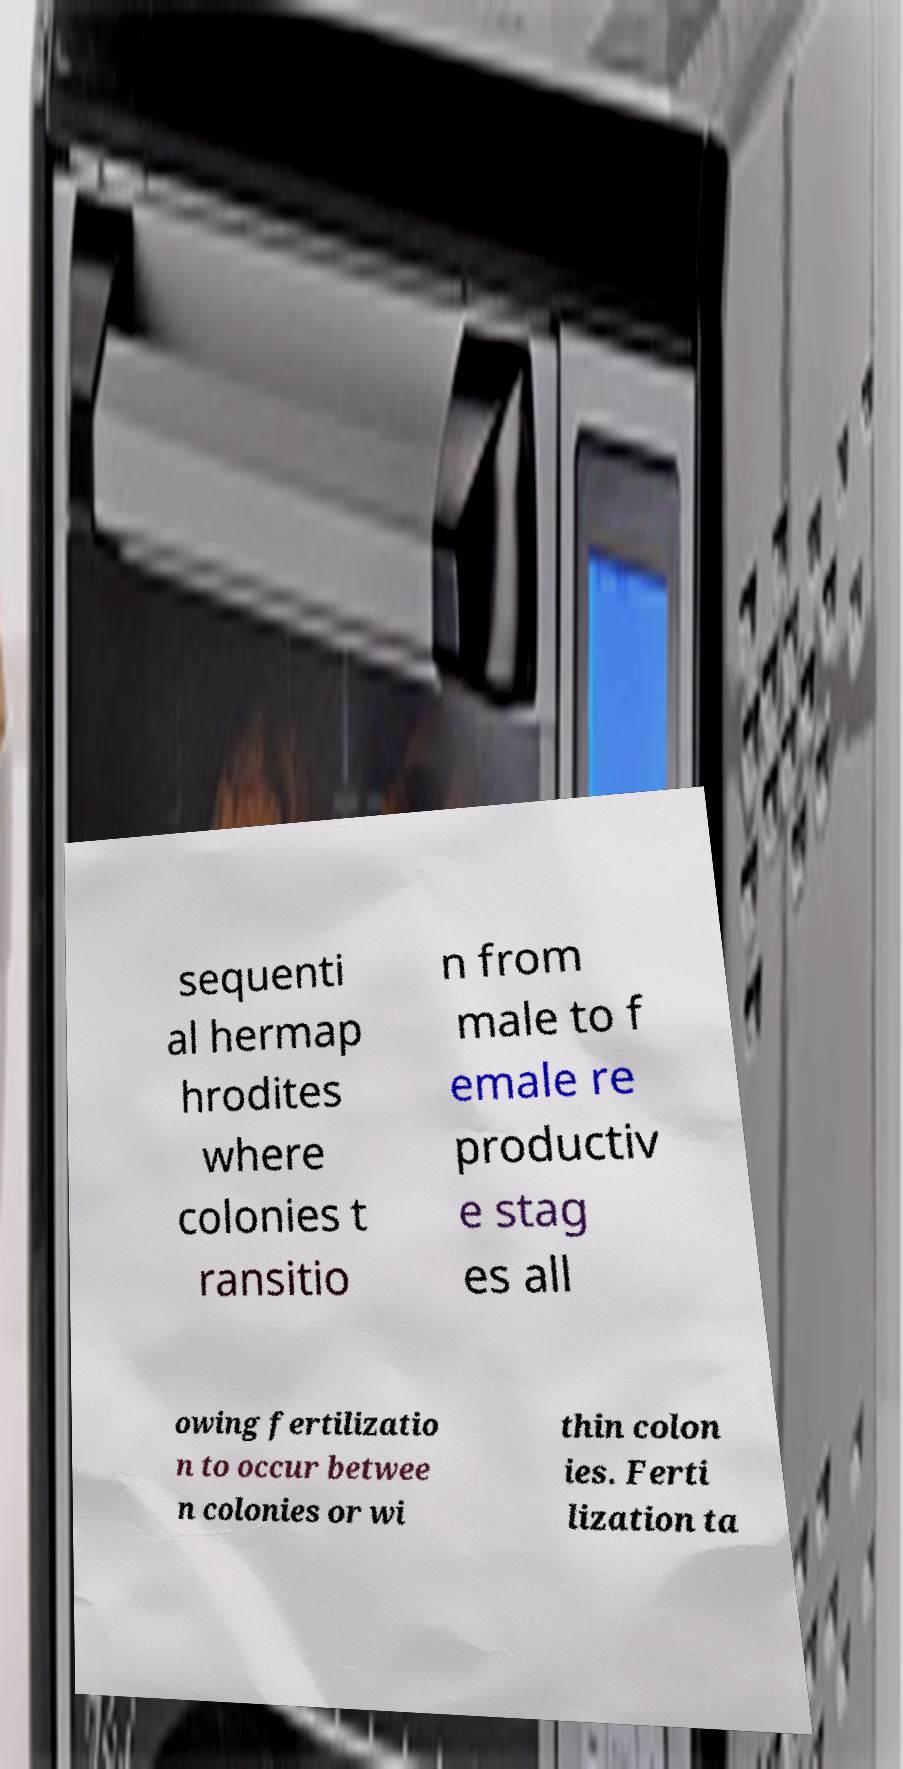Please identify and transcribe the text found in this image. sequenti al hermap hrodites where colonies t ransitio n from male to f emale re productiv e stag es all owing fertilizatio n to occur betwee n colonies or wi thin colon ies. Ferti lization ta 